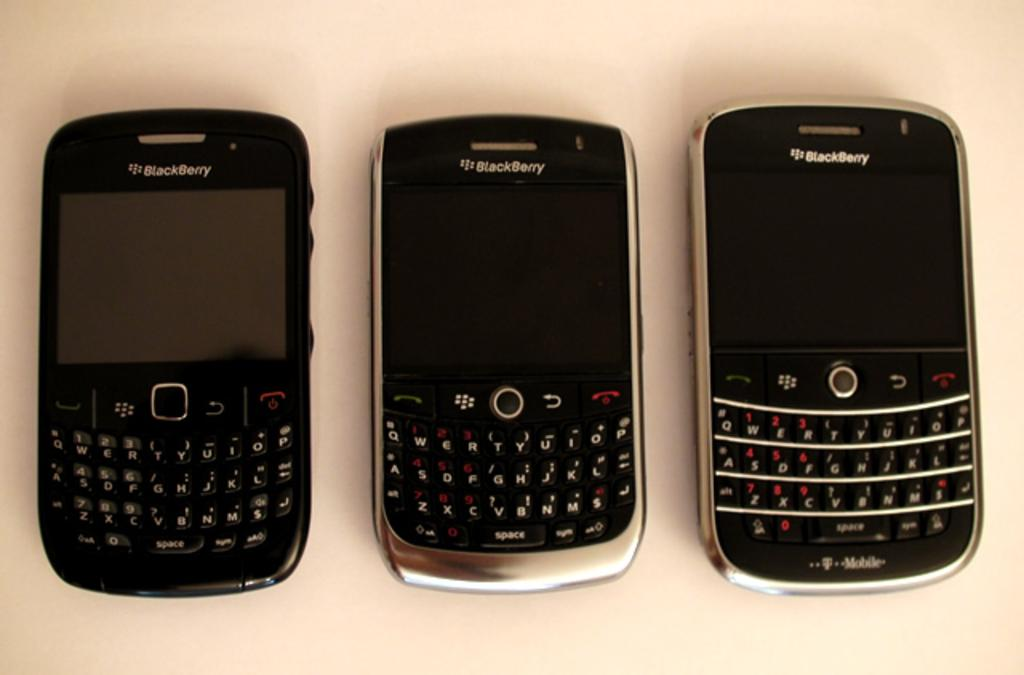<image>
Summarize the visual content of the image. Three cell phones are on a white surface and they all say Blackberry on top. 